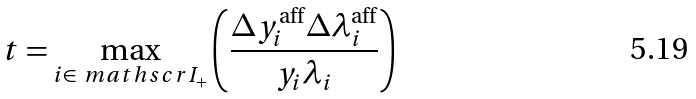<formula> <loc_0><loc_0><loc_500><loc_500>t = \max _ { i \in \ m a t h s c r { I } _ { + } } \left ( \frac { \Delta y _ { i } ^ { \text {aff} } \Delta \lambda _ { i } ^ { \text {aff} } } { y _ { i } \lambda _ { i } } \right )</formula> 